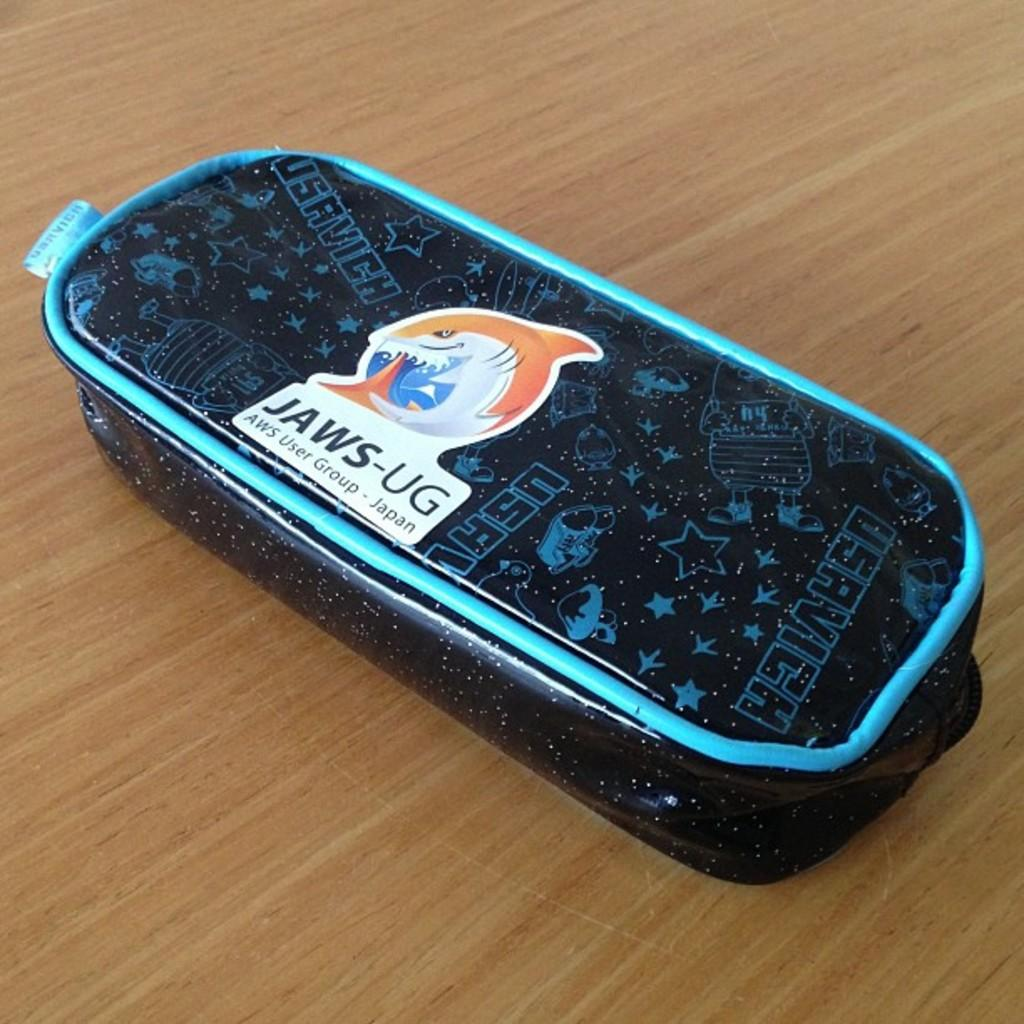What is the color of the object in the image? The object in the image is black. What type of surface is the object placed on? The object is placed on a wooden floor. Where can you buy chalk in the image? There is no shop or chalk present in the image. 